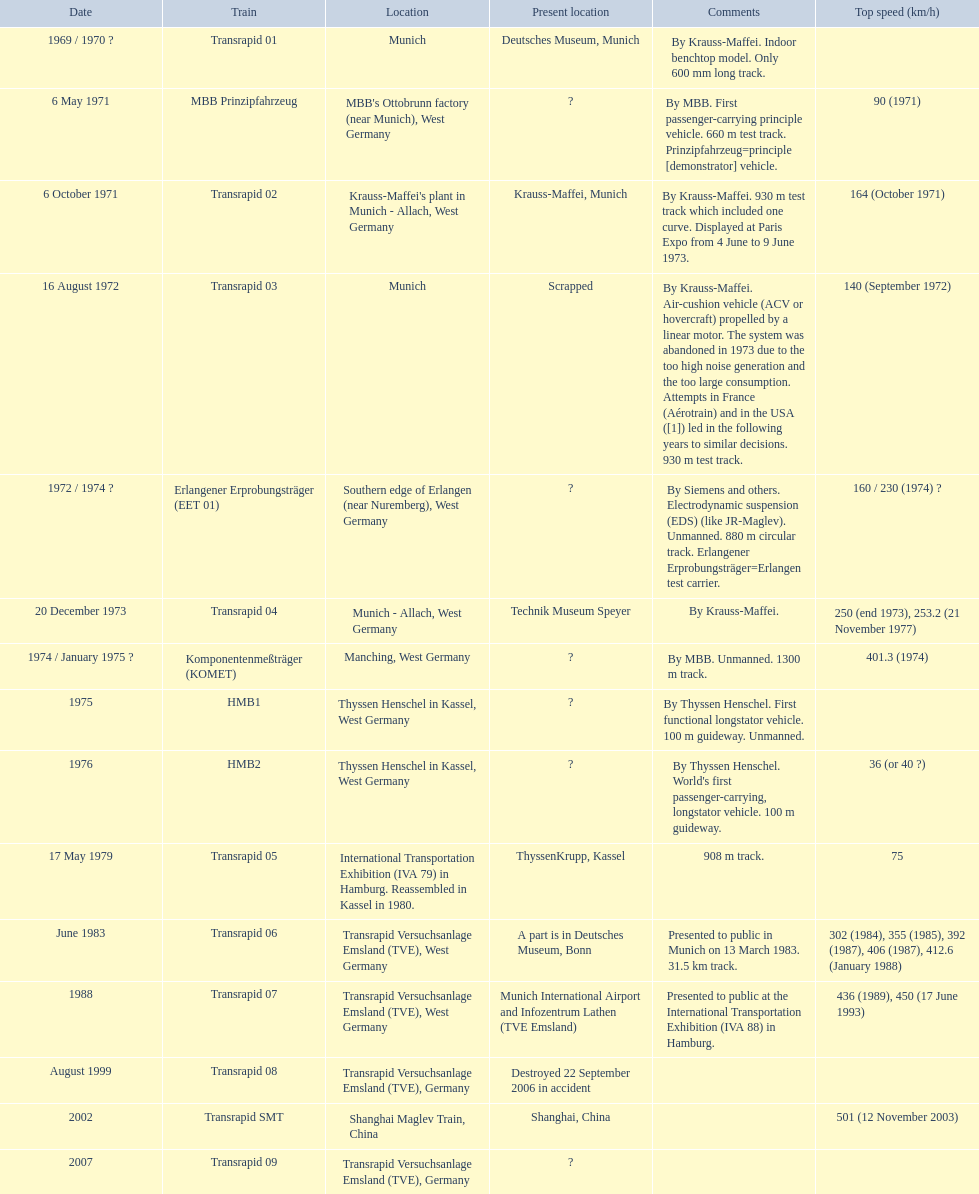Can you provide information on all the trains? Transrapid 01, MBB Prinzipfahrzeug, Transrapid 02, Transrapid 03, Erlangener Erprobungsträger (EET 01), Transrapid 04, Komponentenmeßträger (KOMET), HMB1, HMB2, Transrapid 05, Transrapid 06, Transrapid 07, Transrapid 08, Transrapid SMT, Transrapid 09. Do we know the locations of all the trains? Deutsches Museum, Munich, Krauss-Maffei, Munich, Scrapped, Technik Museum Speyer, ThyssenKrupp, Kassel, A part is in Deutsches Museum, Bonn, Munich International Airport and Infozentrum Lathen (TVE Emsland), Destroyed 22 September 2006 in accident, Shanghai, China. Which trains among them have been scrapped? Transrapid 03. Can you parse all the data within this table? {'header': ['Date', 'Train', 'Location', 'Present location', 'Comments', 'Top speed (km/h)'], 'rows': [['1969 / 1970\xa0?', 'Transrapid 01', 'Munich', 'Deutsches Museum, Munich', 'By Krauss-Maffei. Indoor benchtop model. Only 600\xa0mm long track.', ''], ['6 May 1971', 'MBB Prinzipfahrzeug', "MBB's Ottobrunn factory (near Munich), West Germany", '?', 'By MBB. First passenger-carrying principle vehicle. 660 m test track. Prinzipfahrzeug=principle [demonstrator] vehicle.', '90 (1971)'], ['6 October 1971', 'Transrapid 02', "Krauss-Maffei's plant in Munich - Allach, West Germany", 'Krauss-Maffei, Munich', 'By Krauss-Maffei. 930 m test track which included one curve. Displayed at Paris Expo from 4 June to 9 June 1973.', '164 (October 1971)'], ['16 August 1972', 'Transrapid 03', 'Munich', 'Scrapped', 'By Krauss-Maffei. Air-cushion vehicle (ACV or hovercraft) propelled by a linear motor. The system was abandoned in 1973 due to the too high noise generation and the too large consumption. Attempts in France (Aérotrain) and in the USA ([1]) led in the following years to similar decisions. 930 m test track.', '140 (September 1972)'], ['1972 / 1974\xa0?', 'Erlangener Erprobungsträger (EET 01)', 'Southern edge of Erlangen (near Nuremberg), West Germany', '?', 'By Siemens and others. Electrodynamic suspension (EDS) (like JR-Maglev). Unmanned. 880 m circular track. Erlangener Erprobungsträger=Erlangen test carrier.', '160 / 230 (1974)\xa0?'], ['20 December 1973', 'Transrapid 04', 'Munich - Allach, West Germany', 'Technik Museum Speyer', 'By Krauss-Maffei.', '250 (end 1973), 253.2 (21 November 1977)'], ['1974 / January 1975\xa0?', 'Komponentenmeßträger (KOMET)', 'Manching, West Germany', '?', 'By MBB. Unmanned. 1300 m track.', '401.3 (1974)'], ['1975', 'HMB1', 'Thyssen Henschel in Kassel, West Germany', '?', 'By Thyssen Henschel. First functional longstator vehicle. 100 m guideway. Unmanned.', ''], ['1976', 'HMB2', 'Thyssen Henschel in Kassel, West Germany', '?', "By Thyssen Henschel. World's first passenger-carrying, longstator vehicle. 100 m guideway.", '36 (or 40\xa0?)'], ['17 May 1979', 'Transrapid 05', 'International Transportation Exhibition (IVA 79) in Hamburg. Reassembled in Kassel in 1980.', 'ThyssenKrupp, Kassel', '908 m track.', '75'], ['June 1983', 'Transrapid 06', 'Transrapid Versuchsanlage Emsland (TVE), West Germany', 'A part is in Deutsches Museum, Bonn', 'Presented to public in Munich on 13 March 1983. 31.5\xa0km track.', '302 (1984), 355 (1985), 392 (1987), 406 (1987), 412.6 (January 1988)'], ['1988', 'Transrapid 07', 'Transrapid Versuchsanlage Emsland (TVE), West Germany', 'Munich International Airport and Infozentrum Lathen (TVE Emsland)', 'Presented to public at the International Transportation Exhibition (IVA 88) in Hamburg.', '436 (1989), 450 (17 June 1993)'], ['August 1999', 'Transrapid 08', 'Transrapid Versuchsanlage Emsland (TVE), Germany', 'Destroyed 22 September 2006 in accident', '', ''], ['2002', 'Transrapid SMT', 'Shanghai Maglev Train, China', 'Shanghai, China', '', '501 (12 November 2003)'], ['2007', 'Transrapid 09', 'Transrapid Versuchsanlage Emsland (TVE), Germany', '?', '', '']]} 